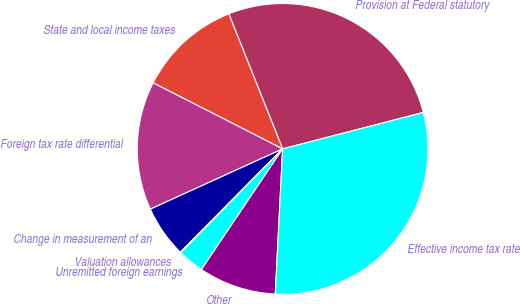Convert chart to OTSL. <chart><loc_0><loc_0><loc_500><loc_500><pie_chart><fcel>Provision at Federal statutory<fcel>State and local income taxes<fcel>Foreign tax rate differential<fcel>Change in measurement of an<fcel>Valuation allowances<fcel>Unremitted foreign earnings<fcel>Other<fcel>Effective income tax rate<nl><fcel>27.0%<fcel>11.46%<fcel>14.31%<fcel>5.77%<fcel>0.08%<fcel>2.92%<fcel>8.62%<fcel>29.84%<nl></chart> 